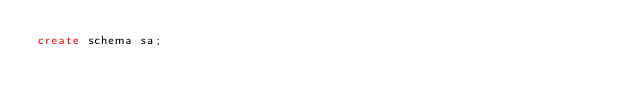<code> <loc_0><loc_0><loc_500><loc_500><_SQL_>create schema sa;

</code> 